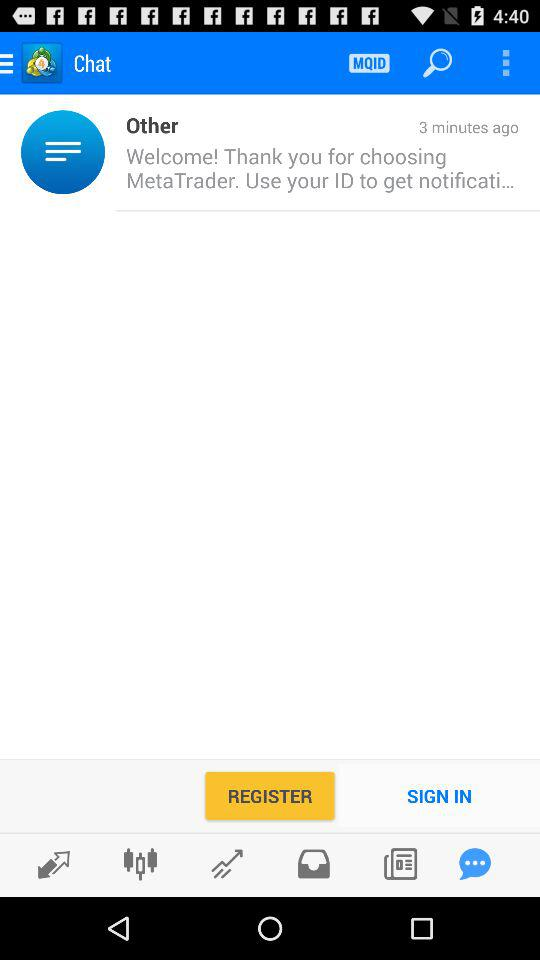What is the name of the application? The name of the application is "MetaTrader 4". 